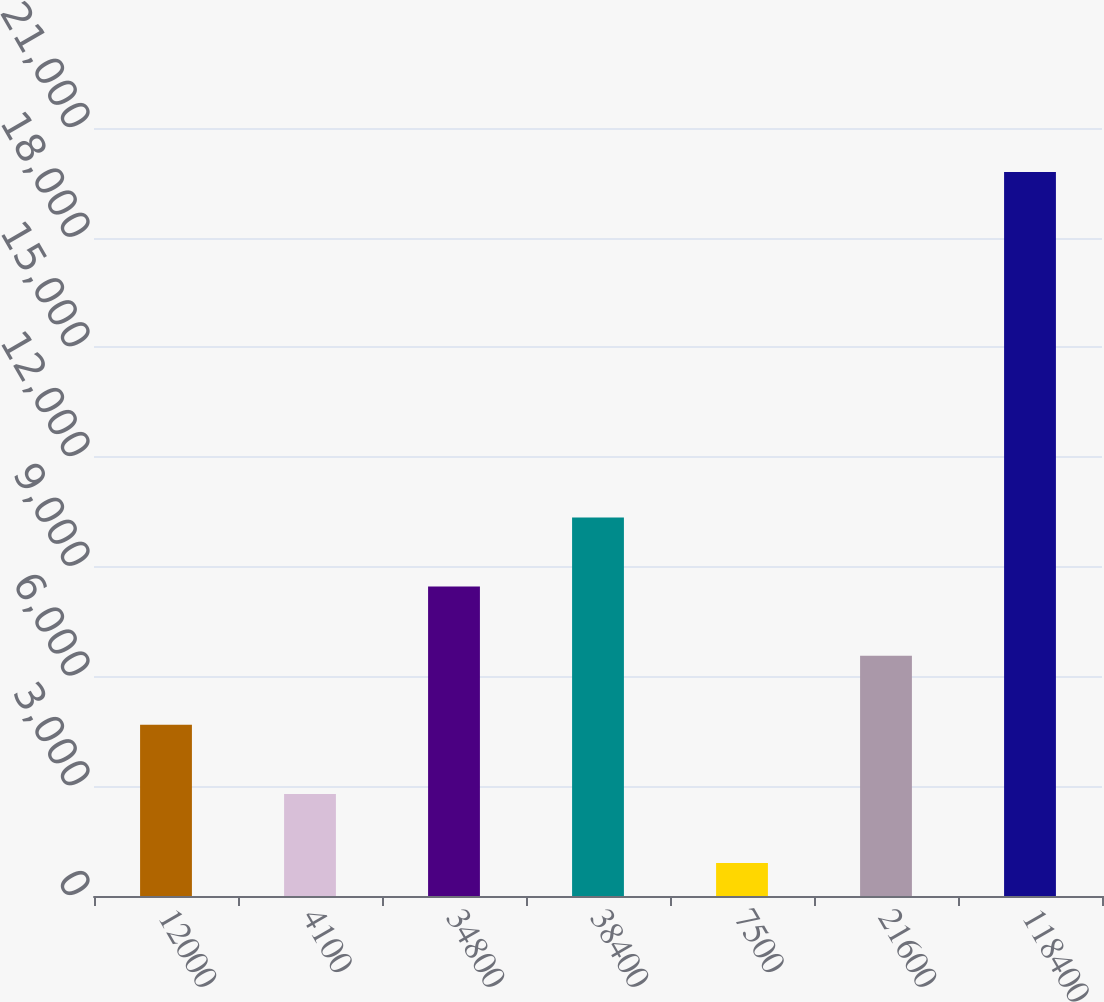<chart> <loc_0><loc_0><loc_500><loc_500><bar_chart><fcel>12000<fcel>4100<fcel>34800<fcel>38400<fcel>7500<fcel>21600<fcel>118400<nl><fcel>4680<fcel>2790<fcel>8460<fcel>10350<fcel>900<fcel>6570<fcel>19800<nl></chart> 